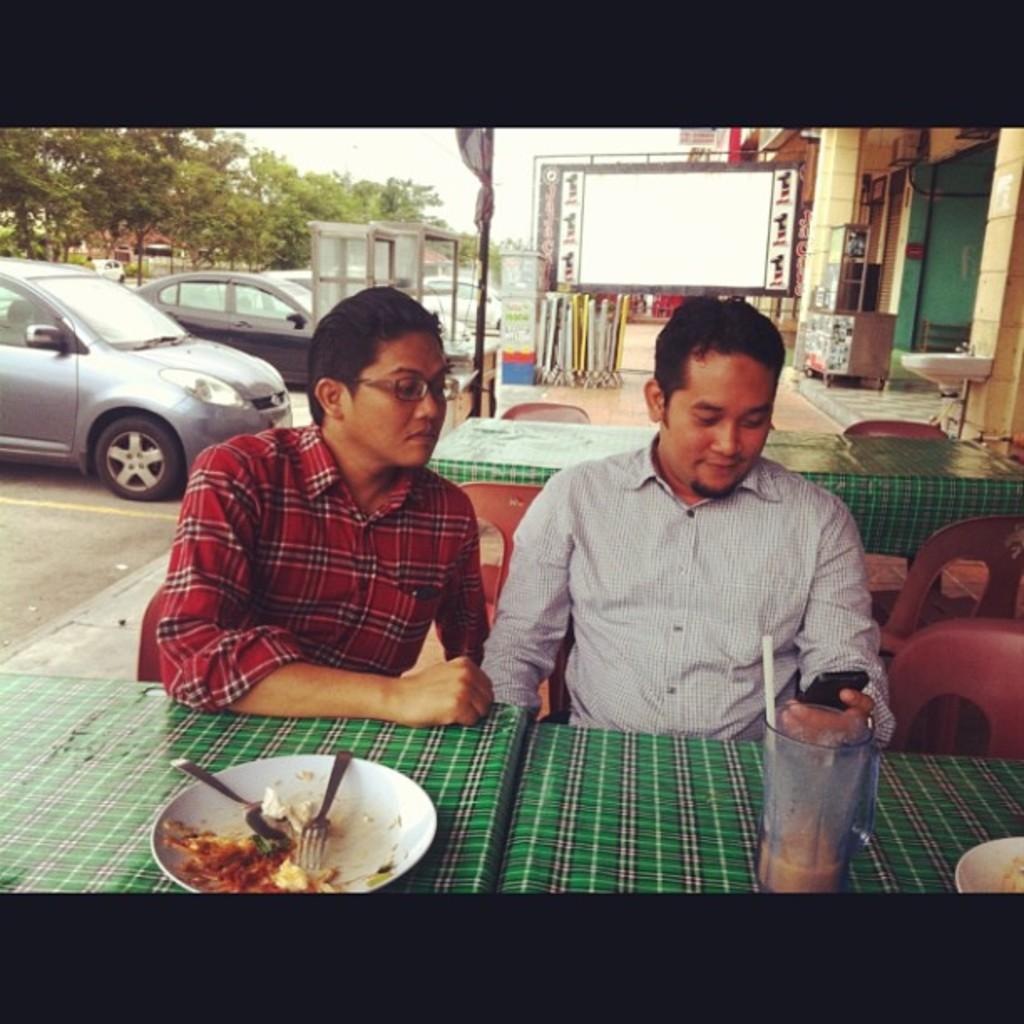Describe this image in one or two sentences. In this picture I can see there are two men sitting and and the person on to left is operating a mobile phone and the person on to left is wearing spectacles is looking into the mobile. In the backdrop there is another table with chairs and there is a building, trees, cars parked here and there are few cars moving on the road. The sky is clear. 